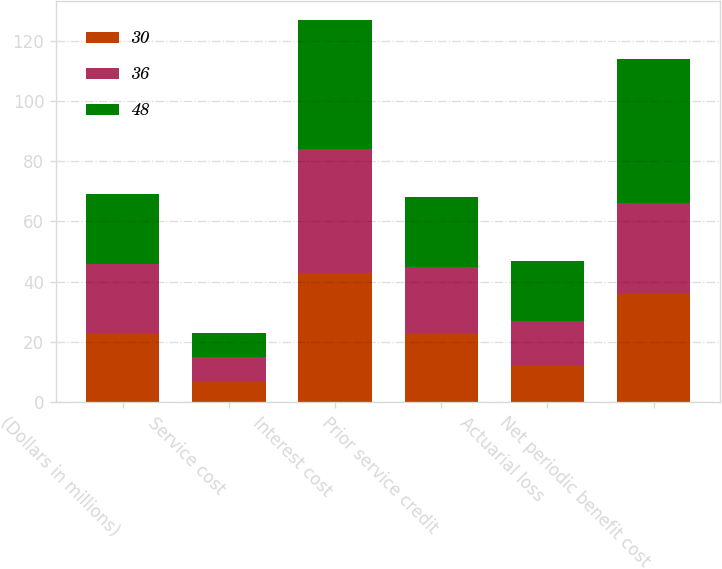<chart> <loc_0><loc_0><loc_500><loc_500><stacked_bar_chart><ecel><fcel>(Dollars in millions)<fcel>Service cost<fcel>Interest cost<fcel>Prior service credit<fcel>Actuarial loss<fcel>Net periodic benefit cost<nl><fcel>30<fcel>23<fcel>7<fcel>43<fcel>23<fcel>12<fcel>36<nl><fcel>36<fcel>23<fcel>8<fcel>41<fcel>22<fcel>15<fcel>30<nl><fcel>48<fcel>23<fcel>8<fcel>43<fcel>23<fcel>20<fcel>48<nl></chart> 